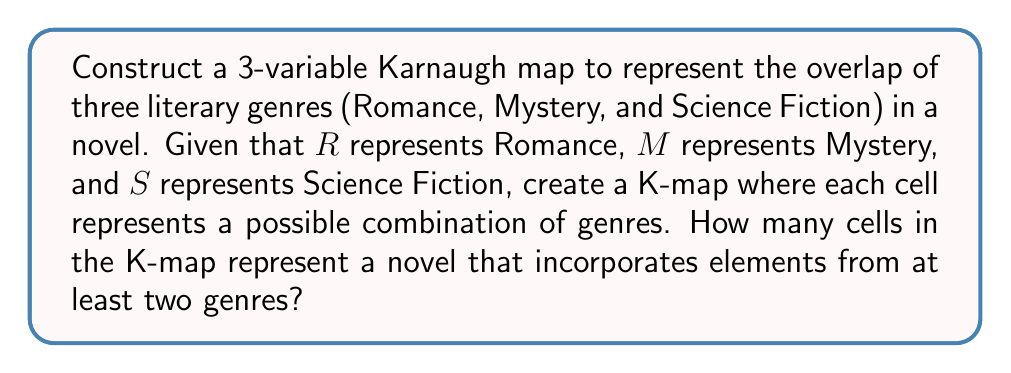Teach me how to tackle this problem. Let's approach this step-by-step:

1) First, we need to create a 3-variable Karnaugh map. The variables are R, M, and S.

2) The K-map will have $2^3 = 8$ cells, arranged in a 2x4 grid:

   [asy]
   unitsize(1cm);
   draw((0,0)--(4,0)--(4,2)--(0,2)--cycle);
   draw((2,0)--(2,2));
   draw((0,1)--(4,1));
   label("00", (1,1.5));
   label("01", (3,1.5));
   label("11", (3,0.5));
   label("10", (1,0.5));
   label("$\overline{R}M$", (0,2.5));
   label("$RS$", (-0.5,1));
   [/asy]

3) Each cell represents a combination of genres:
   - 000: No genres (not a valid novel)
   - 001: Only Science Fiction
   - 010: Only Mystery
   - 011: Mystery and Science Fiction
   - 100: Only Romance
   - 101: Romance and Science Fiction
   - 110: Romance and Mystery
   - 111: All three genres

4) We're looking for cells that represent at least two genres. These are:
   - 011: Mystery and Science Fiction
   - 101: Romance and Science Fiction
   - 110: Romance and Mystery
   - 111: All three genres

5) Counting these cells, we find that there are 4 cells that represent novels with at least two genres.
Answer: 4 cells 